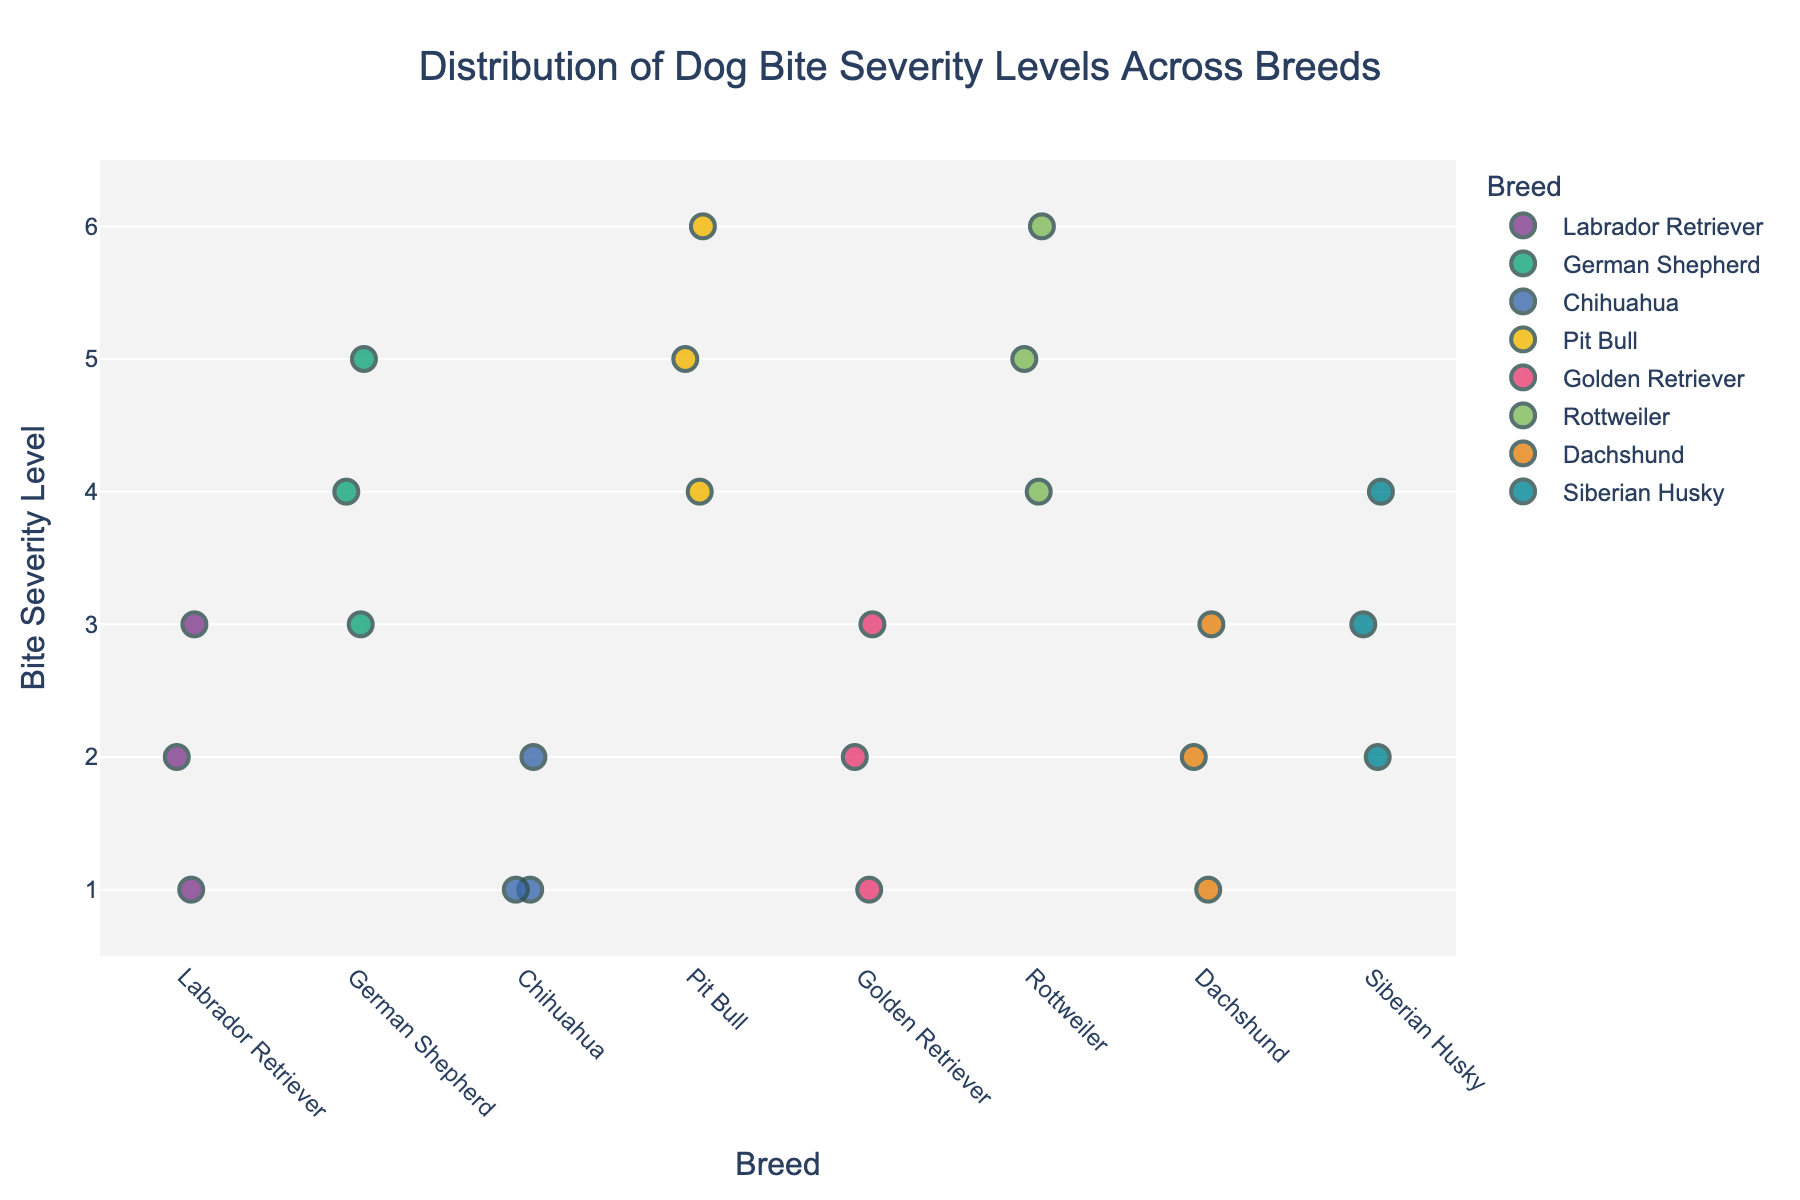what is the title of the figure? The title is displayed at the top center of the figure and generally summarizes the main subject of the plot. In this case, it specifically mentions the distribution of bite severity levels across different dog breeds.
Answer: Distribution of Dog Bite Severity Levels Across Breeds What is the highest bite severity level observed in the plot? The y-axis indicates the bite severity levels, ranging from 1 to 6. A marker is seen at the highest level on the y-axis.
Answer: 6 How many breeds are represented in the plot? Each unique name on the x-axis represents a different breed. Counting these names will give the total number of breeds in the plot.
Answer: 8 Which breed shows the most severe bite level? By examining the y-axis and looking for the highest severity level marker, we see which breed has markers at the highest point. In this case, Pit Bull and Rottweiler both have severity levels of 6. So both breeds should be mentioned.
Answer: Pit Bull, Rottweiler Which breed displays the least variability in bite severity levels? Variability can be assessed by looking at the spread of markers for each breed along the y-axis. The breed with the least spread in its markers has the least variability.
Answer: Chihuahua Compare the median bite severity levels of German Shepherd and Golden Retriever. Which one is higher? To find the median, look at the middle value of each breed's markers on the y-axis. For German Shepherd, the middle value is 4. For Golden Retriever, it's 2.
Answer: German Shepherd What is the average bite severity level of Labrador Retrievers? To find the average severity level, add the severity levels for all Labrador Retrievers and divide by the number of observations: (2 + 1 + 3) / 3 = 6 / 3.
Answer: 2 Are there any breeds with only low severity levels (1-2)? Look at all the markers for each breed on the y-axis; any breed with all markers at severity levels 1 or 2 are considered to have only low severity levels.
Answer: Chihuahua Which breed has the widest range of bite severity levels? The range is determined by the difference between the highest and lowest severity levels for each breed. The breed with the largest difference has the widest range.
Answer: Pit Bull What is the total number of bite severity observations for the Rottweiler breed? Count the number of markers displayed for Rottweiler on the x-axis to find the total number of observations.
Answer: 3 